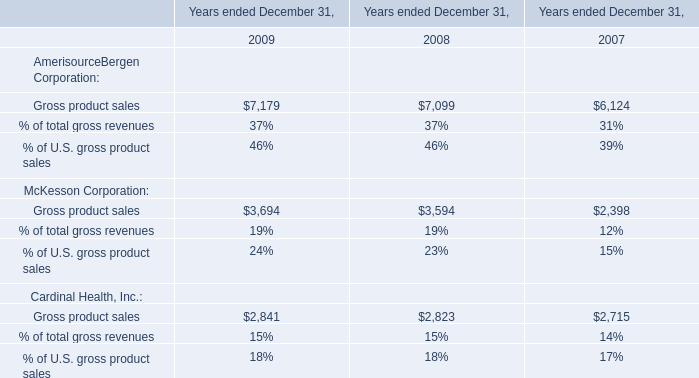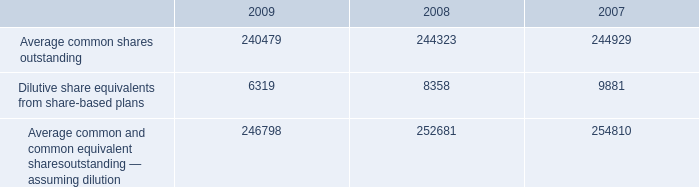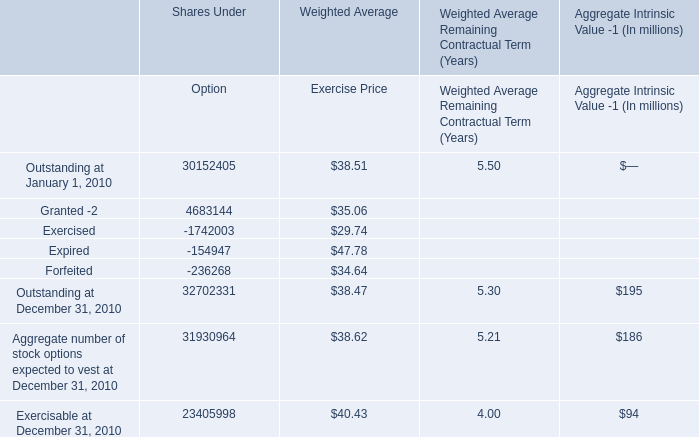What's the 90 % of Weighted Average Exercise Price of total Outstanding at January 1, 2010? 
Computations: (0.9 * 38.51)
Answer: 34.659. What is the average amount of Average common shares outstanding of 2007, and Gross product sales of Years ended December 31, 2008 ? 
Computations: ((244929.0 + 7099.0) / 2)
Answer: 126014.0. 